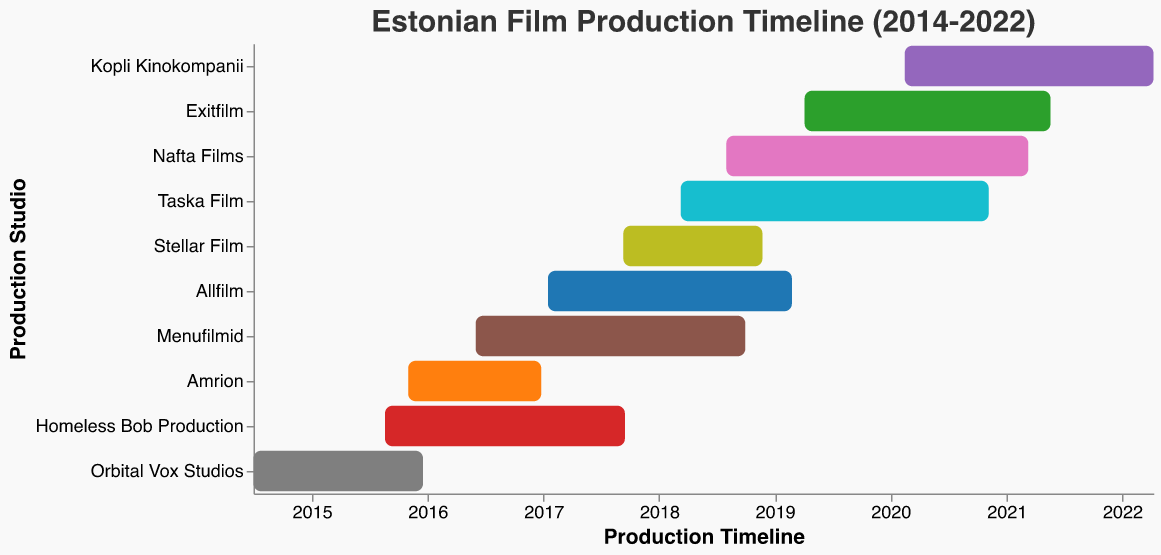What is the title of the figure? The title of the figure is prominently displayed at the top.
Answer: Estonian Film Production Timeline (2014-2022) Which production had the longest timeline? To determine the production with the longest timeline, compare the start and end dates for each project and identify the one with the greatest difference.
Answer: Melchior the Apothecary What was the production period for "Firebird"? Locate "Firebird" on the chart and note its start and end dates as shown on the Gantt Chart.
Answer: August 1, 2018 - March 11, 2021 How many studios had projects starting in 2017? Identify the bars that begin in 2017 by looking at the x-axis. Count the number of studios corresponding to these bars.
Answer: Three Which studio completed two projects within the shortest timespan? Compare the duration of different projects completed by various studios and identify the shortest one.
Answer: Homeless Bob Production (November) Between "The Polar Boy" and "The Last Relic", which had an earlier start date? Compare the start dates for both "The Polar Boy" and "The Last Relic" as shown on the x-axis of the Gantt Chart.
Answer: The Last Relic What is the average production duration across all projects? Calculate the duration for each project by subtracting the start date from the end date, sum them up, and divide by the number of projects.
Answer: 2 years Which studio's project finished the latest in the timeline? Identify the project that ends last on the x-axis and then refer to the corresponding studio on the y-axis.
Answer: Kopli Kinokompanii (Melchior the Apothecary) How many different colors are used in the chart? Count the number of distinct colors assigned to the different studios in the Gantt Chart.
Answer: Ten What was the production period for "Truth and Justice" by Allfilm? Locate the "Truth and Justice" project in the chart and read its corresponding start and end dates from the timeline.
Answer: January 15, 2017 - February 24, 2019 